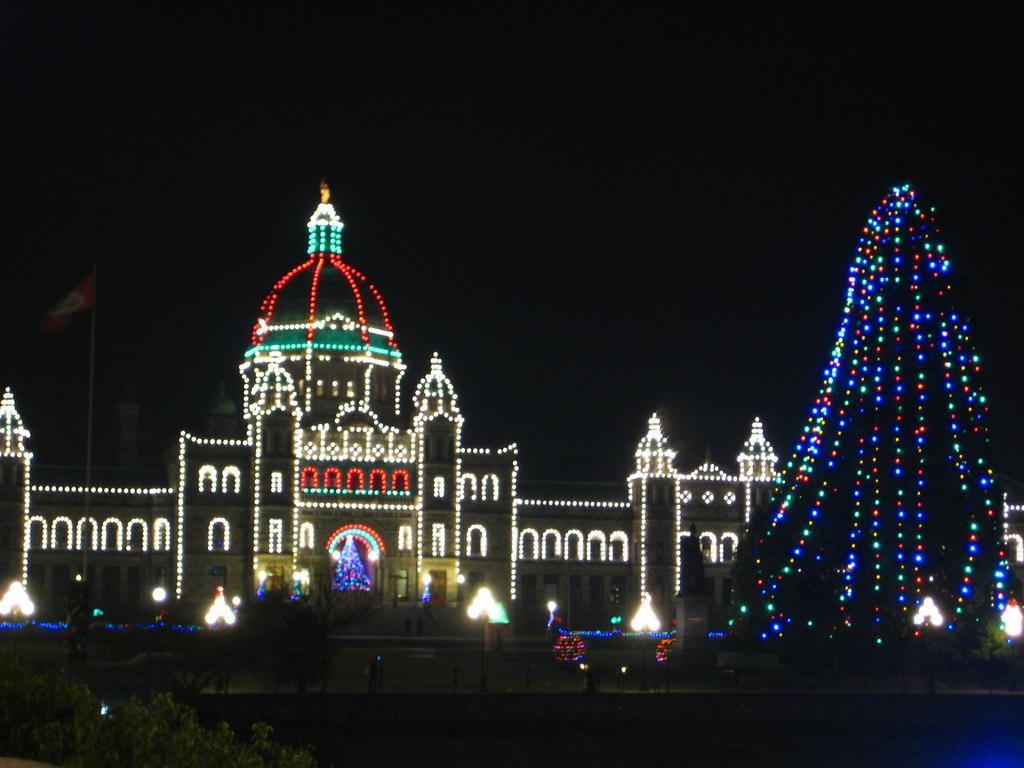How would you summarize this image in a sentence or two? There are plants, grassland, decorative lights on the building in the image. 